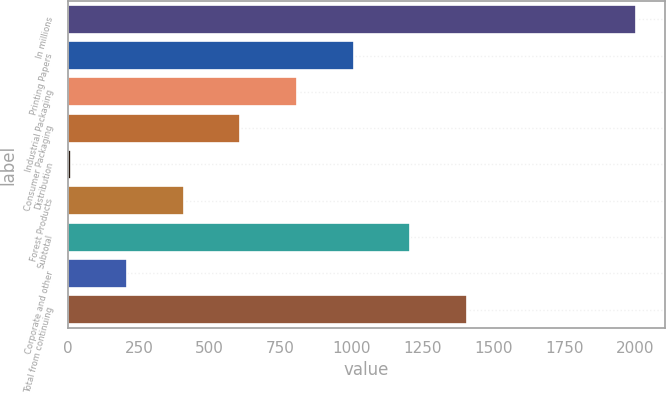Convert chart. <chart><loc_0><loc_0><loc_500><loc_500><bar_chart><fcel>In millions<fcel>Printing Papers<fcel>Industrial Packaging<fcel>Consumer Packaging<fcel>Distribution<fcel>Forest Products<fcel>Subtotal<fcel>Corporate and other<fcel>Total from continuing<nl><fcel>2005<fcel>1007<fcel>807.4<fcel>607.8<fcel>9<fcel>408.2<fcel>1206.6<fcel>208.6<fcel>1406.2<nl></chart> 